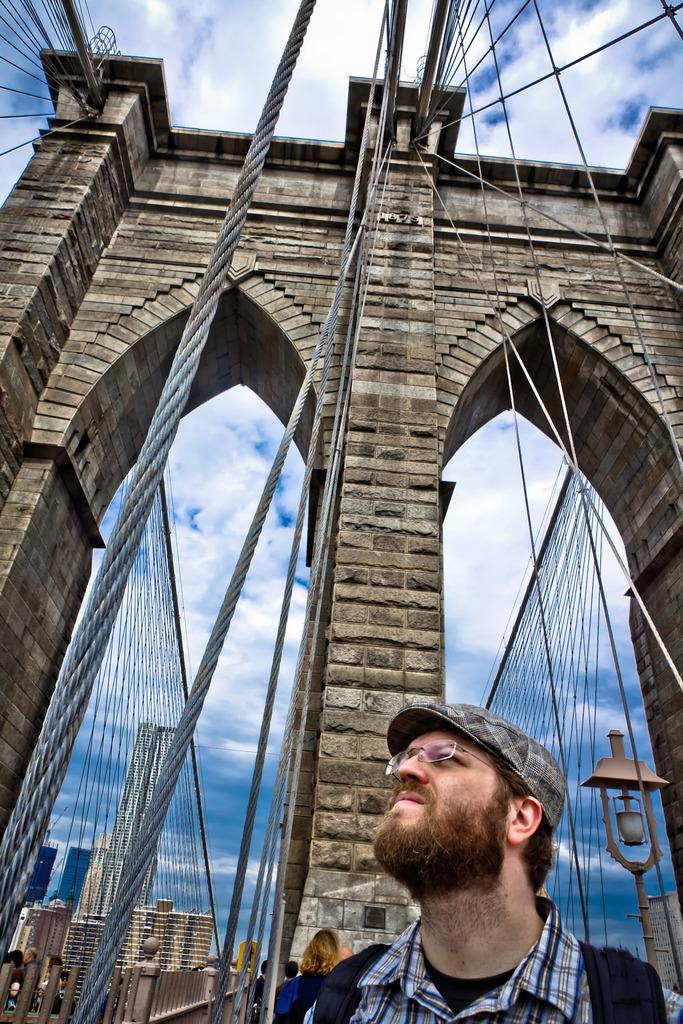How would you summarize this image in a sentence or two? In the picture I can see a man on the bottom right side. I can see a bridge construction. In the background, I can see the buildings. There are clouds in the sky. 